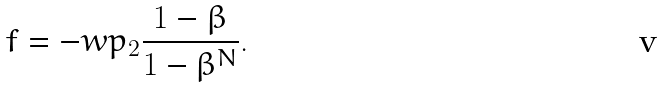<formula> <loc_0><loc_0><loc_500><loc_500>f = - w p _ { 2 } \frac { 1 - \beta } { 1 - \beta ^ { N } } .</formula> 